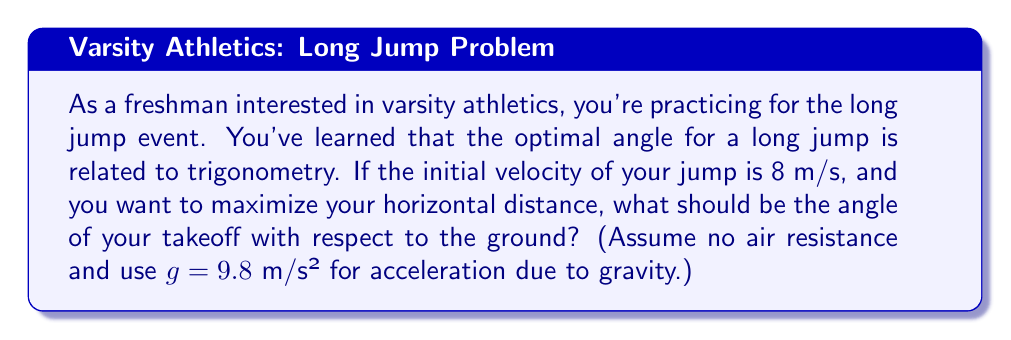Can you answer this question? To find the optimal angle for a long jump, we need to use the principles of projectile motion and trigonometry. The horizontal distance traveled in a projectile motion is given by the equation:

$$R = \frac{v^2 \sin(2\theta)}{g}$$

Where:
$R$ is the horizontal distance
$v$ is the initial velocity
$\theta$ is the angle of takeoff
$g$ is the acceleration due to gravity

To maximize $R$, we need to maximize $\sin(2\theta)$. The maximum value of sine is 1, which occurs when its argument is 90°. Therefore:

$$2\theta = 90°$$
$$\theta = 45°$$

This result shows that the optimal angle for achieving the maximum horizontal distance in a projectile motion (like a long jump) is 45° with respect to the ground.

To verify this mathematically:

1) The derivative of $\sin(2\theta)$ with respect to $\theta$ is:
   $$\frac{d}{d\theta}[\sin(2\theta)] = 2\cos(2\theta)$$

2) Setting this equal to zero to find the maximum:
   $$2\cos(2\theta) = 0$$
   $$\cos(2\theta) = 0$$

3) This occurs when $2\theta = 90°$ or $\theta = 45°$

Therefore, the optimal angle for your long jump takeoff should be 45° to maximize your horizontal distance.
Answer: The optimal angle for the long jump takeoff is 45°. 